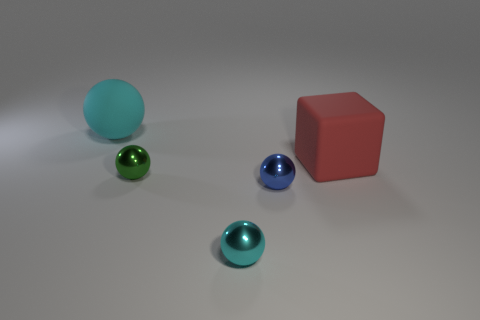Subtract 1 balls. How many balls are left? 3 Add 4 large purple metallic objects. How many objects exist? 9 Subtract all blocks. How many objects are left? 4 Add 5 red things. How many red things are left? 6 Add 5 small purple metallic things. How many small purple metallic things exist? 5 Subtract 0 yellow cubes. How many objects are left? 5 Subtract all green objects. Subtract all red rubber cubes. How many objects are left? 3 